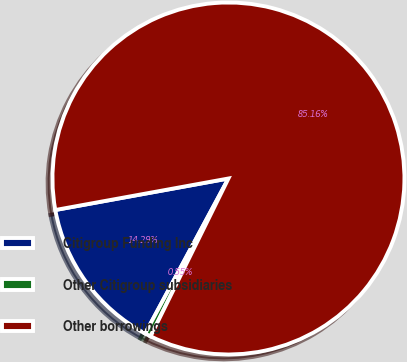Convert chart. <chart><loc_0><loc_0><loc_500><loc_500><pie_chart><fcel>Citigroup Funding Inc<fcel>Other Citigroup subsidiaries<fcel>Other borrowings<nl><fcel>14.29%<fcel>0.55%<fcel>85.16%<nl></chart> 